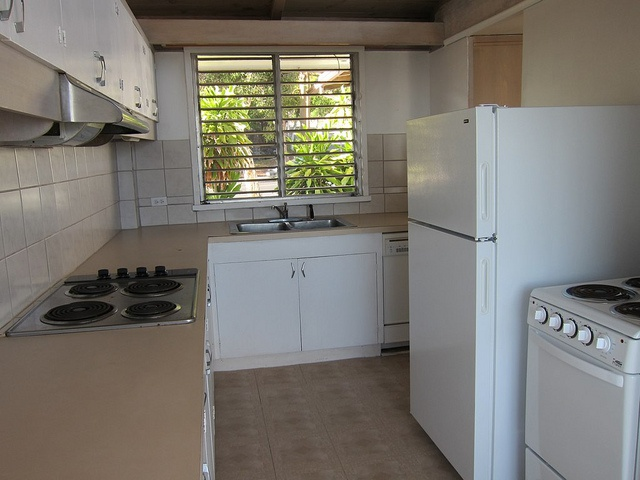Describe the objects in this image and their specific colors. I can see refrigerator in gray, darkgray, and lightblue tones, oven in gray, black, and darkgray tones, and sink in gray, black, and darkgray tones in this image. 